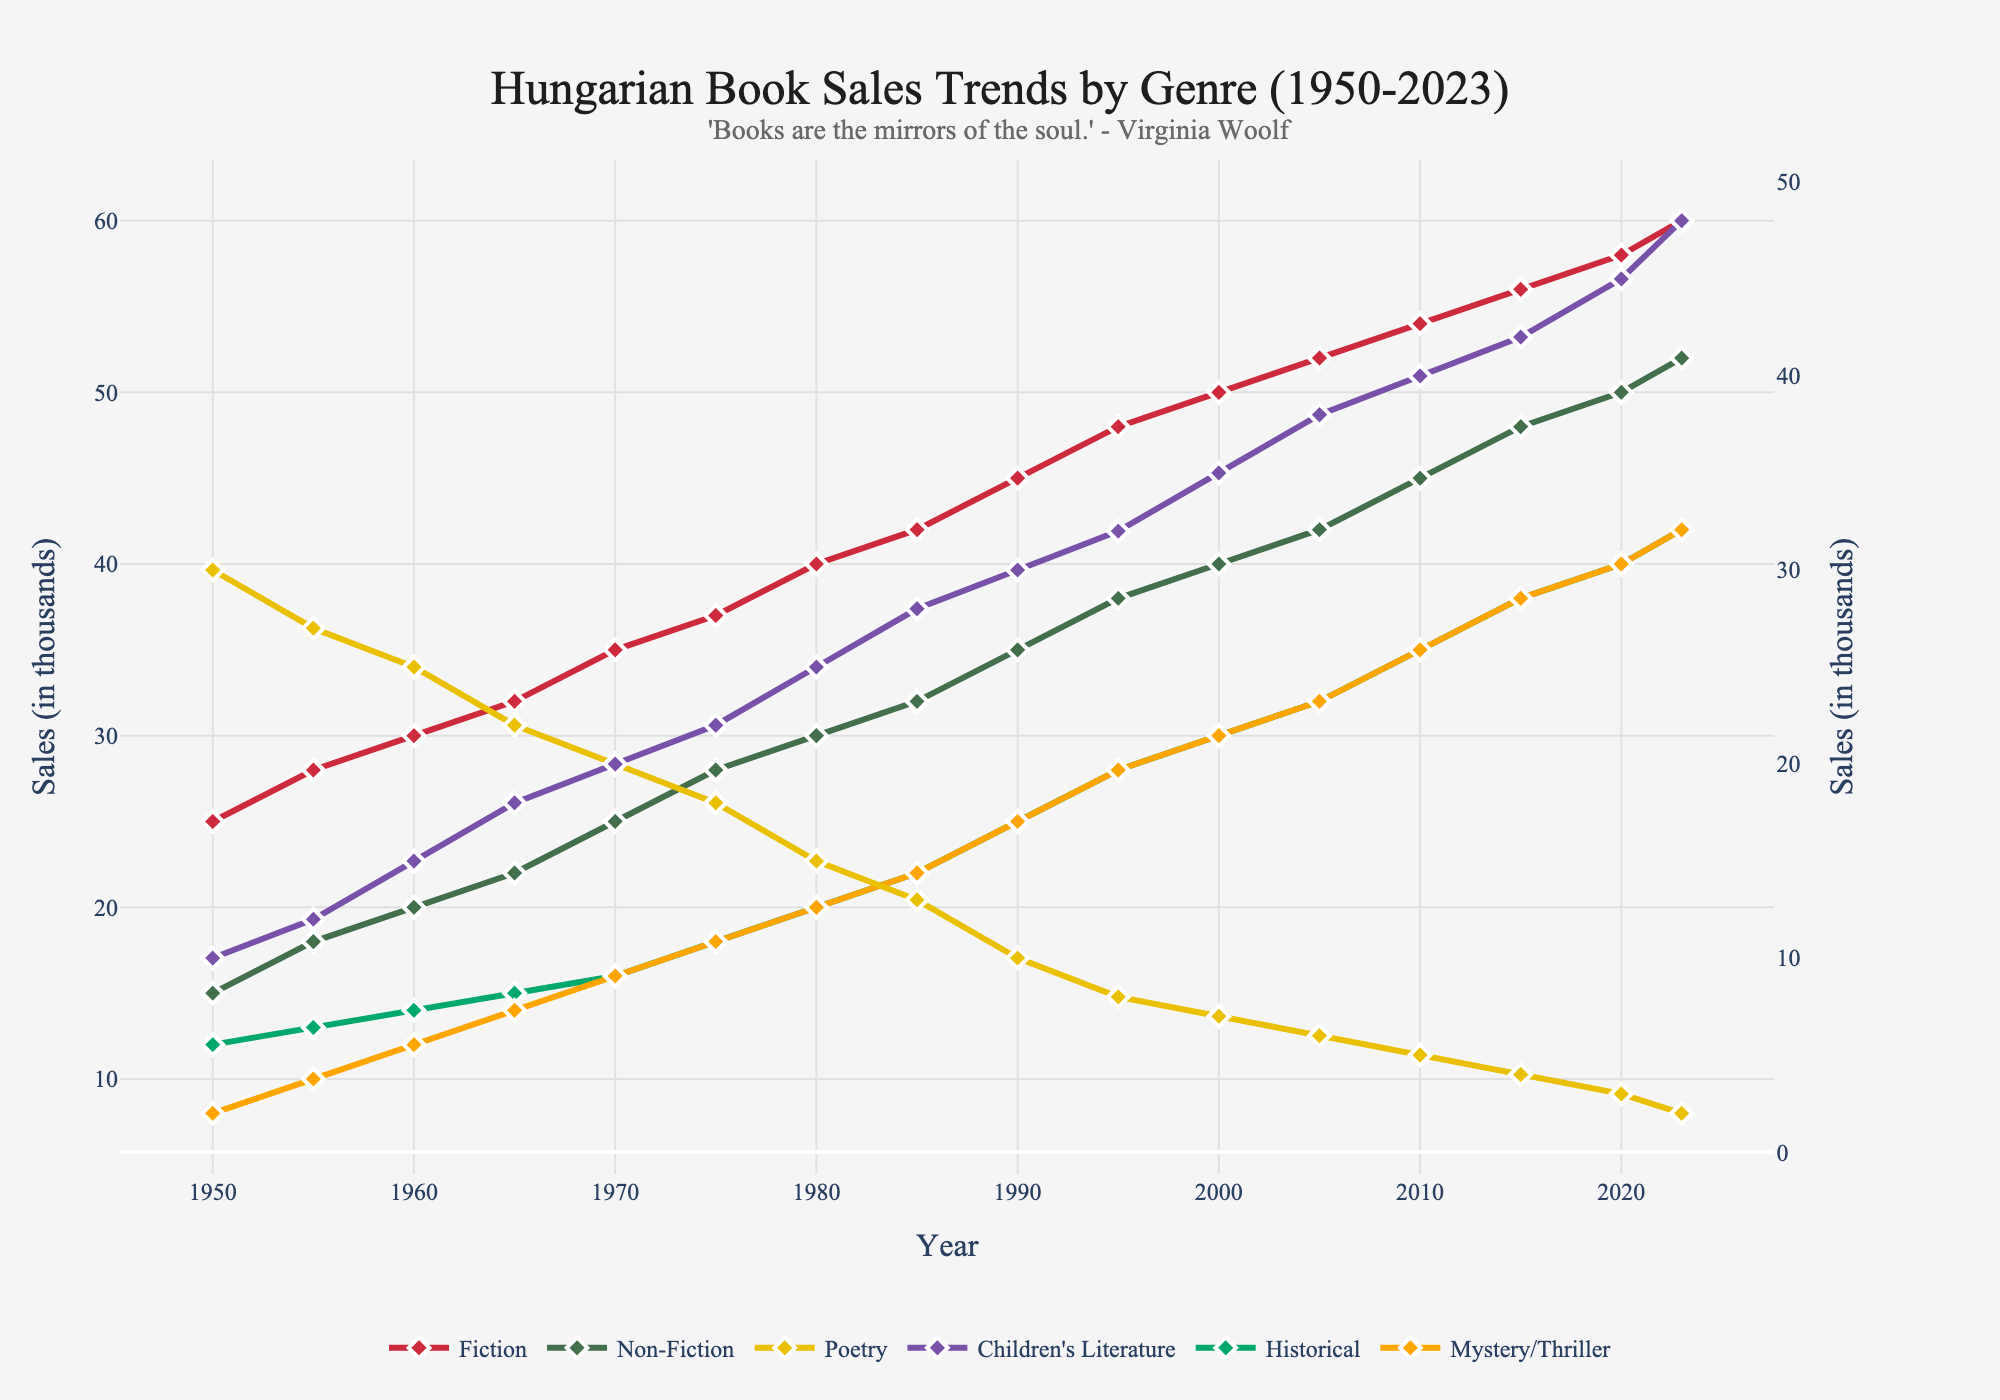Which genre had the highest sales in 2023? Looking at the end of the chart for the year 2023, the genre with the highest sales is Fiction since it reaches the peak value.
Answer: Fiction What is the overall trend in sales for Non-Fiction from 1950 to 2023? Track the line for Non-Fiction from 1950 to 2023. Observe that the trend is consistently increasing over the years.
Answer: Increasing By how much did Children's Literature sales increase from 1950 to 2023? In 1950, Children's Literature had sales of 10,000, and in 2023, it had sales of 48,000. The difference is 48,000 - 10,000.
Answer: 38 Which genres have seen a decline in sales over the years? Identify the genres that show a downward slope or consistent decrease. Poetry sales decrease from 30,000 in 1950 to 2,000 in 2023.
Answer: Poetry In what year did Historical sales surpass 20,000? Find the point where the Historical genre line crosses the 20,000 mark. This happens between 1975 and 1980, specifically in 1980.
Answer: 1980 How do Fiction and Mystery/Thriller sales compare in 2023? Look at the chart for the year 2023. Compare the ending points of Fiction and Mystery/Thriller lines. Fiction is higher than Mystery/Thriller.
Answer: Fiction > Mystery/Thriller What is the total sales of all genres combined in the year 2000? Sum the sales figures for each genre in the year 2000: 50 (Fiction) + 40 (Non-Fiction) + 7 (Poetry) + 35 (Children's Literature) + 30 (Historical) + 30 (Mystery/Thriller).
Answer: 192 How did sales of Poetry change between 1980 and 1990? Look at the points for Poetry in 1980 and 1990. Note the decrease from 15,000 in 1980 to 10,000 in 1990.
Answer: Decreased by 5 Which genre had a spike in sales around the 1980s? Notice any sharp increases in the lines around 1980. Fiction shows a significant rise from 1975 to 1985.
Answer: Fiction 